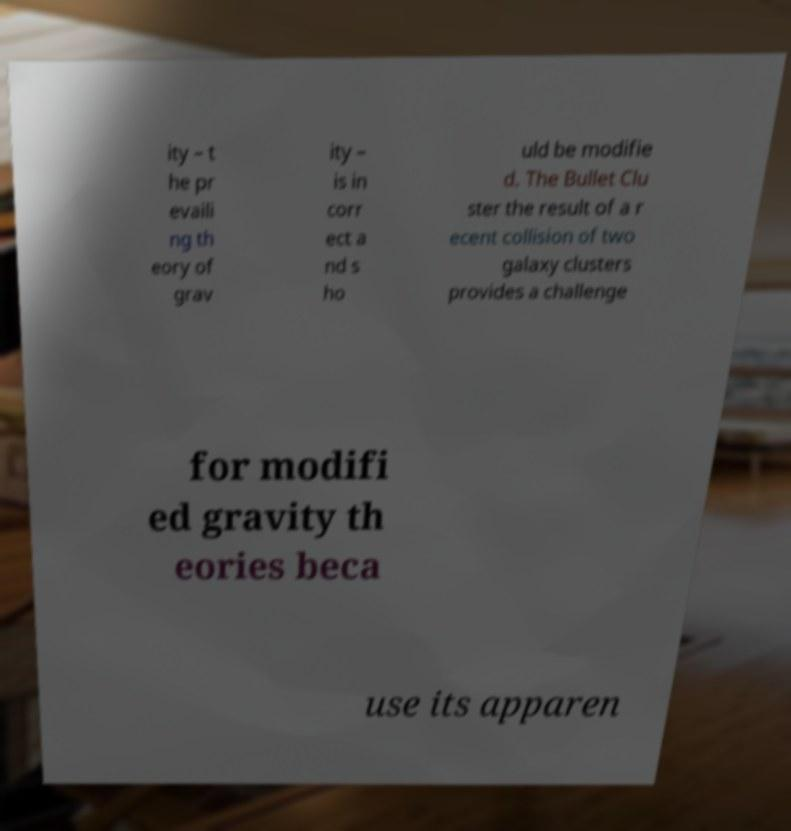There's text embedded in this image that I need extracted. Can you transcribe it verbatim? ity – t he pr evaili ng th eory of grav ity – is in corr ect a nd s ho uld be modifie d. The Bullet Clu ster the result of a r ecent collision of two galaxy clusters provides a challenge for modifi ed gravity th eories beca use its apparen 